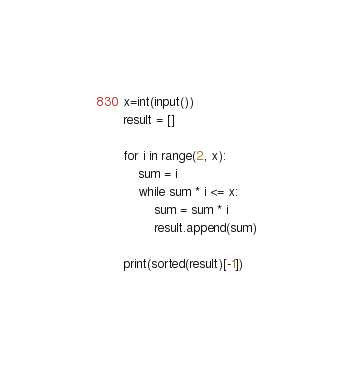Convert code to text. <code><loc_0><loc_0><loc_500><loc_500><_Python_>x=int(input())
result = []

for i in range(2, x):
    sum = i
    while sum * i <= x:
        sum = sum * i
        result.append(sum)

print(sorted(result)[-1])
</code> 